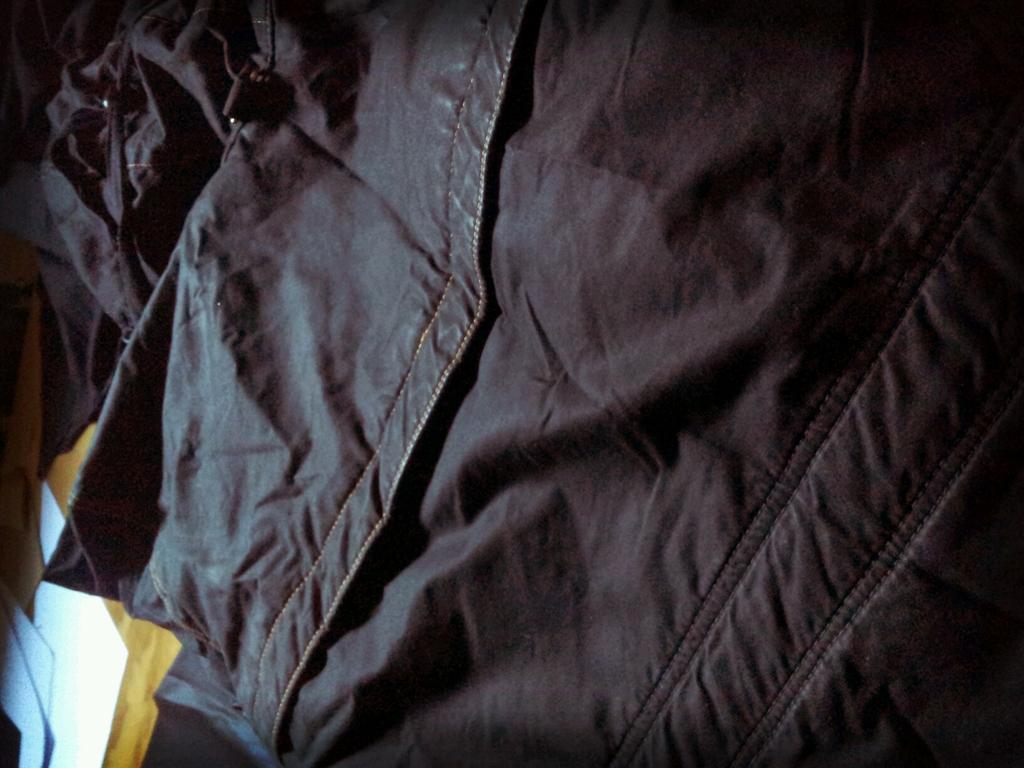How would you summarize this image in a sentence or two? In this image I can see a black colour cloth. On the bottom left side of the image I can see a yellow colour thing and on it I can see three white colour papers like things. 